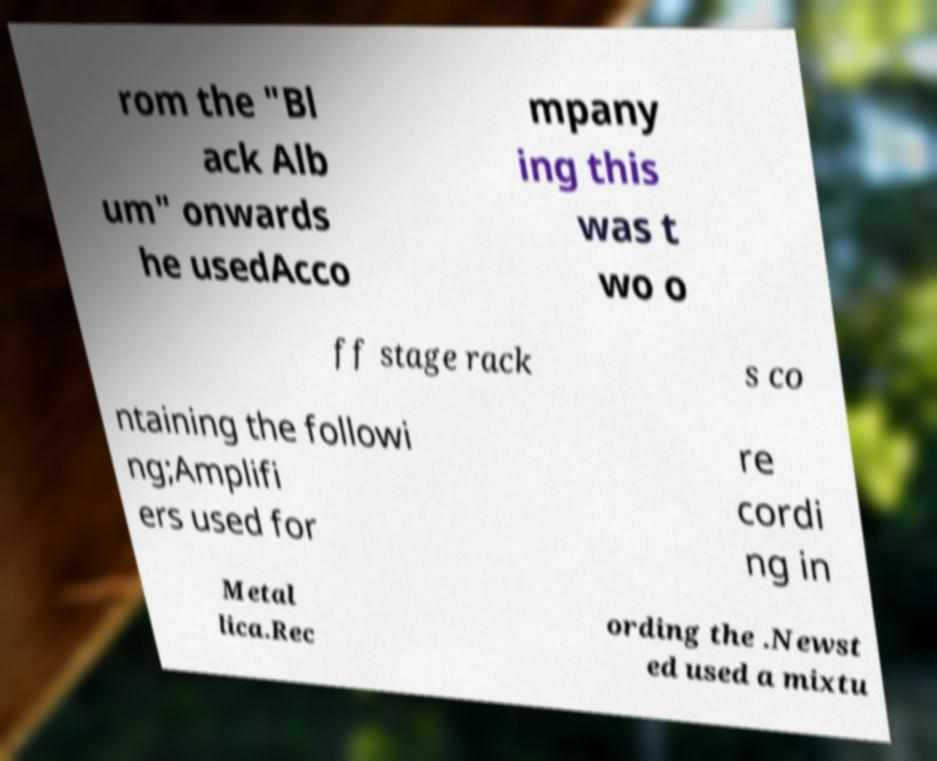What messages or text are displayed in this image? I need them in a readable, typed format. rom the "Bl ack Alb um" onwards he usedAcco mpany ing this was t wo o ff stage rack s co ntaining the followi ng;Amplifi ers used for re cordi ng in Metal lica.Rec ording the .Newst ed used a mixtu 